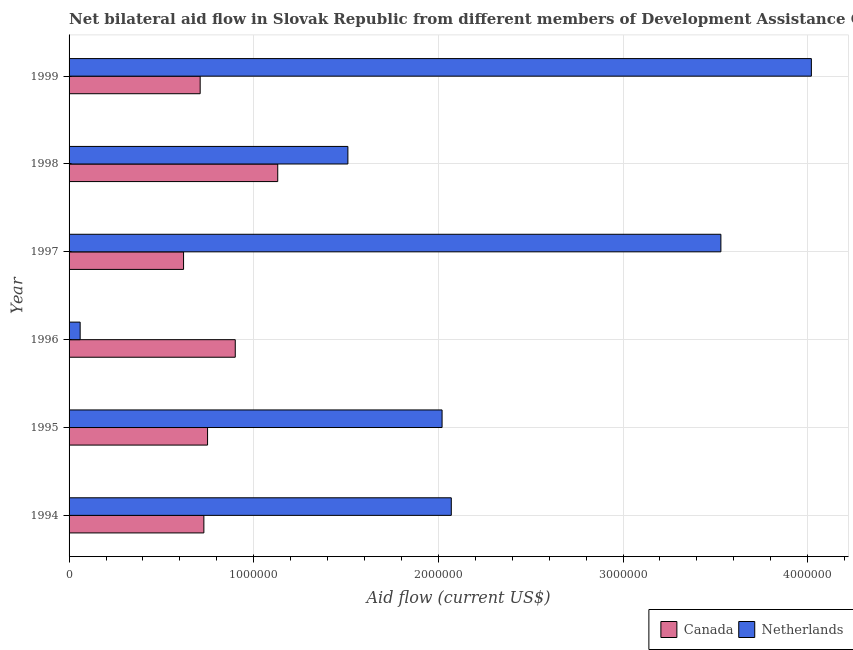How many groups of bars are there?
Give a very brief answer. 6. How many bars are there on the 6th tick from the top?
Make the answer very short. 2. How many bars are there on the 1st tick from the bottom?
Offer a terse response. 2. In how many cases, is the number of bars for a given year not equal to the number of legend labels?
Your response must be concise. 0. What is the amount of aid given by canada in 1998?
Provide a succinct answer. 1.13e+06. Across all years, what is the maximum amount of aid given by netherlands?
Your answer should be compact. 4.02e+06. Across all years, what is the minimum amount of aid given by netherlands?
Keep it short and to the point. 6.00e+04. In which year was the amount of aid given by netherlands maximum?
Offer a very short reply. 1999. What is the total amount of aid given by netherlands in the graph?
Ensure brevity in your answer.  1.32e+07. What is the difference between the amount of aid given by netherlands in 1997 and that in 1998?
Provide a short and direct response. 2.02e+06. What is the difference between the amount of aid given by netherlands in 1997 and the amount of aid given by canada in 1994?
Ensure brevity in your answer.  2.80e+06. What is the average amount of aid given by canada per year?
Make the answer very short. 8.07e+05. In the year 1996, what is the difference between the amount of aid given by canada and amount of aid given by netherlands?
Provide a short and direct response. 8.40e+05. In how many years, is the amount of aid given by canada greater than 3000000 US$?
Make the answer very short. 0. What is the ratio of the amount of aid given by canada in 1996 to that in 1999?
Provide a succinct answer. 1.27. Is the difference between the amount of aid given by netherlands in 1995 and 1999 greater than the difference between the amount of aid given by canada in 1995 and 1999?
Provide a succinct answer. No. What is the difference between the highest and the lowest amount of aid given by canada?
Offer a very short reply. 5.10e+05. In how many years, is the amount of aid given by netherlands greater than the average amount of aid given by netherlands taken over all years?
Offer a very short reply. 2. Is the sum of the amount of aid given by canada in 1996 and 1999 greater than the maximum amount of aid given by netherlands across all years?
Offer a very short reply. No. How many bars are there?
Your response must be concise. 12. What is the difference between two consecutive major ticks on the X-axis?
Offer a terse response. 1.00e+06. Does the graph contain any zero values?
Provide a succinct answer. No. Where does the legend appear in the graph?
Give a very brief answer. Bottom right. How many legend labels are there?
Offer a very short reply. 2. How are the legend labels stacked?
Give a very brief answer. Horizontal. What is the title of the graph?
Give a very brief answer. Net bilateral aid flow in Slovak Republic from different members of Development Assistance Committee. What is the label or title of the X-axis?
Offer a terse response. Aid flow (current US$). What is the label or title of the Y-axis?
Provide a succinct answer. Year. What is the Aid flow (current US$) of Canada in 1994?
Give a very brief answer. 7.30e+05. What is the Aid flow (current US$) in Netherlands in 1994?
Offer a terse response. 2.07e+06. What is the Aid flow (current US$) of Canada in 1995?
Your answer should be very brief. 7.50e+05. What is the Aid flow (current US$) in Netherlands in 1995?
Give a very brief answer. 2.02e+06. What is the Aid flow (current US$) of Canada in 1996?
Offer a terse response. 9.00e+05. What is the Aid flow (current US$) of Netherlands in 1996?
Your answer should be compact. 6.00e+04. What is the Aid flow (current US$) of Canada in 1997?
Offer a terse response. 6.20e+05. What is the Aid flow (current US$) of Netherlands in 1997?
Your response must be concise. 3.53e+06. What is the Aid flow (current US$) of Canada in 1998?
Make the answer very short. 1.13e+06. What is the Aid flow (current US$) in Netherlands in 1998?
Provide a succinct answer. 1.51e+06. What is the Aid flow (current US$) in Canada in 1999?
Give a very brief answer. 7.10e+05. What is the Aid flow (current US$) of Netherlands in 1999?
Provide a short and direct response. 4.02e+06. Across all years, what is the maximum Aid flow (current US$) of Canada?
Give a very brief answer. 1.13e+06. Across all years, what is the maximum Aid flow (current US$) in Netherlands?
Give a very brief answer. 4.02e+06. Across all years, what is the minimum Aid flow (current US$) of Canada?
Keep it short and to the point. 6.20e+05. Across all years, what is the minimum Aid flow (current US$) of Netherlands?
Keep it short and to the point. 6.00e+04. What is the total Aid flow (current US$) in Canada in the graph?
Your response must be concise. 4.84e+06. What is the total Aid flow (current US$) of Netherlands in the graph?
Keep it short and to the point. 1.32e+07. What is the difference between the Aid flow (current US$) in Canada in 1994 and that in 1995?
Your response must be concise. -2.00e+04. What is the difference between the Aid flow (current US$) of Netherlands in 1994 and that in 1996?
Provide a short and direct response. 2.01e+06. What is the difference between the Aid flow (current US$) of Netherlands in 1994 and that in 1997?
Your response must be concise. -1.46e+06. What is the difference between the Aid flow (current US$) of Canada in 1994 and that in 1998?
Your response must be concise. -4.00e+05. What is the difference between the Aid flow (current US$) in Netherlands in 1994 and that in 1998?
Offer a terse response. 5.60e+05. What is the difference between the Aid flow (current US$) in Canada in 1994 and that in 1999?
Offer a terse response. 2.00e+04. What is the difference between the Aid flow (current US$) of Netherlands in 1994 and that in 1999?
Your answer should be compact. -1.95e+06. What is the difference between the Aid flow (current US$) of Canada in 1995 and that in 1996?
Your response must be concise. -1.50e+05. What is the difference between the Aid flow (current US$) in Netherlands in 1995 and that in 1996?
Ensure brevity in your answer.  1.96e+06. What is the difference between the Aid flow (current US$) of Canada in 1995 and that in 1997?
Provide a succinct answer. 1.30e+05. What is the difference between the Aid flow (current US$) in Netherlands in 1995 and that in 1997?
Provide a succinct answer. -1.51e+06. What is the difference between the Aid flow (current US$) in Canada in 1995 and that in 1998?
Keep it short and to the point. -3.80e+05. What is the difference between the Aid flow (current US$) in Netherlands in 1995 and that in 1998?
Make the answer very short. 5.10e+05. What is the difference between the Aid flow (current US$) of Netherlands in 1995 and that in 1999?
Ensure brevity in your answer.  -2.00e+06. What is the difference between the Aid flow (current US$) of Canada in 1996 and that in 1997?
Give a very brief answer. 2.80e+05. What is the difference between the Aid flow (current US$) of Netherlands in 1996 and that in 1997?
Keep it short and to the point. -3.47e+06. What is the difference between the Aid flow (current US$) of Canada in 1996 and that in 1998?
Provide a succinct answer. -2.30e+05. What is the difference between the Aid flow (current US$) in Netherlands in 1996 and that in 1998?
Provide a succinct answer. -1.45e+06. What is the difference between the Aid flow (current US$) of Netherlands in 1996 and that in 1999?
Provide a succinct answer. -3.96e+06. What is the difference between the Aid flow (current US$) in Canada in 1997 and that in 1998?
Provide a succinct answer. -5.10e+05. What is the difference between the Aid flow (current US$) of Netherlands in 1997 and that in 1998?
Give a very brief answer. 2.02e+06. What is the difference between the Aid flow (current US$) of Netherlands in 1997 and that in 1999?
Provide a succinct answer. -4.90e+05. What is the difference between the Aid flow (current US$) of Netherlands in 1998 and that in 1999?
Your answer should be compact. -2.51e+06. What is the difference between the Aid flow (current US$) in Canada in 1994 and the Aid flow (current US$) in Netherlands in 1995?
Ensure brevity in your answer.  -1.29e+06. What is the difference between the Aid flow (current US$) of Canada in 1994 and the Aid flow (current US$) of Netherlands in 1996?
Offer a very short reply. 6.70e+05. What is the difference between the Aid flow (current US$) in Canada in 1994 and the Aid flow (current US$) in Netherlands in 1997?
Provide a short and direct response. -2.80e+06. What is the difference between the Aid flow (current US$) of Canada in 1994 and the Aid flow (current US$) of Netherlands in 1998?
Ensure brevity in your answer.  -7.80e+05. What is the difference between the Aid flow (current US$) in Canada in 1994 and the Aid flow (current US$) in Netherlands in 1999?
Your response must be concise. -3.29e+06. What is the difference between the Aid flow (current US$) in Canada in 1995 and the Aid flow (current US$) in Netherlands in 1996?
Keep it short and to the point. 6.90e+05. What is the difference between the Aid flow (current US$) of Canada in 1995 and the Aid flow (current US$) of Netherlands in 1997?
Your response must be concise. -2.78e+06. What is the difference between the Aid flow (current US$) of Canada in 1995 and the Aid flow (current US$) of Netherlands in 1998?
Provide a short and direct response. -7.60e+05. What is the difference between the Aid flow (current US$) in Canada in 1995 and the Aid flow (current US$) in Netherlands in 1999?
Provide a succinct answer. -3.27e+06. What is the difference between the Aid flow (current US$) in Canada in 1996 and the Aid flow (current US$) in Netherlands in 1997?
Offer a terse response. -2.63e+06. What is the difference between the Aid flow (current US$) of Canada in 1996 and the Aid flow (current US$) of Netherlands in 1998?
Ensure brevity in your answer.  -6.10e+05. What is the difference between the Aid flow (current US$) of Canada in 1996 and the Aid flow (current US$) of Netherlands in 1999?
Provide a succinct answer. -3.12e+06. What is the difference between the Aid flow (current US$) in Canada in 1997 and the Aid flow (current US$) in Netherlands in 1998?
Keep it short and to the point. -8.90e+05. What is the difference between the Aid flow (current US$) of Canada in 1997 and the Aid flow (current US$) of Netherlands in 1999?
Offer a very short reply. -3.40e+06. What is the difference between the Aid flow (current US$) of Canada in 1998 and the Aid flow (current US$) of Netherlands in 1999?
Make the answer very short. -2.89e+06. What is the average Aid flow (current US$) in Canada per year?
Provide a short and direct response. 8.07e+05. What is the average Aid flow (current US$) of Netherlands per year?
Your answer should be very brief. 2.20e+06. In the year 1994, what is the difference between the Aid flow (current US$) of Canada and Aid flow (current US$) of Netherlands?
Your answer should be very brief. -1.34e+06. In the year 1995, what is the difference between the Aid flow (current US$) in Canada and Aid flow (current US$) in Netherlands?
Ensure brevity in your answer.  -1.27e+06. In the year 1996, what is the difference between the Aid flow (current US$) in Canada and Aid flow (current US$) in Netherlands?
Your answer should be very brief. 8.40e+05. In the year 1997, what is the difference between the Aid flow (current US$) of Canada and Aid flow (current US$) of Netherlands?
Your response must be concise. -2.91e+06. In the year 1998, what is the difference between the Aid flow (current US$) in Canada and Aid flow (current US$) in Netherlands?
Make the answer very short. -3.80e+05. In the year 1999, what is the difference between the Aid flow (current US$) in Canada and Aid flow (current US$) in Netherlands?
Make the answer very short. -3.31e+06. What is the ratio of the Aid flow (current US$) in Canada in 1994 to that in 1995?
Offer a very short reply. 0.97. What is the ratio of the Aid flow (current US$) of Netherlands in 1994 to that in 1995?
Make the answer very short. 1.02. What is the ratio of the Aid flow (current US$) in Canada in 1994 to that in 1996?
Give a very brief answer. 0.81. What is the ratio of the Aid flow (current US$) in Netherlands in 1994 to that in 1996?
Give a very brief answer. 34.5. What is the ratio of the Aid flow (current US$) in Canada in 1994 to that in 1997?
Give a very brief answer. 1.18. What is the ratio of the Aid flow (current US$) of Netherlands in 1994 to that in 1997?
Give a very brief answer. 0.59. What is the ratio of the Aid flow (current US$) in Canada in 1994 to that in 1998?
Give a very brief answer. 0.65. What is the ratio of the Aid flow (current US$) in Netherlands in 1994 to that in 1998?
Make the answer very short. 1.37. What is the ratio of the Aid flow (current US$) of Canada in 1994 to that in 1999?
Offer a very short reply. 1.03. What is the ratio of the Aid flow (current US$) in Netherlands in 1994 to that in 1999?
Your answer should be very brief. 0.51. What is the ratio of the Aid flow (current US$) in Canada in 1995 to that in 1996?
Your response must be concise. 0.83. What is the ratio of the Aid flow (current US$) in Netherlands in 1995 to that in 1996?
Offer a very short reply. 33.67. What is the ratio of the Aid flow (current US$) in Canada in 1995 to that in 1997?
Your answer should be very brief. 1.21. What is the ratio of the Aid flow (current US$) of Netherlands in 1995 to that in 1997?
Offer a very short reply. 0.57. What is the ratio of the Aid flow (current US$) of Canada in 1995 to that in 1998?
Provide a short and direct response. 0.66. What is the ratio of the Aid flow (current US$) in Netherlands in 1995 to that in 1998?
Provide a short and direct response. 1.34. What is the ratio of the Aid flow (current US$) of Canada in 1995 to that in 1999?
Offer a terse response. 1.06. What is the ratio of the Aid flow (current US$) of Netherlands in 1995 to that in 1999?
Your answer should be very brief. 0.5. What is the ratio of the Aid flow (current US$) of Canada in 1996 to that in 1997?
Give a very brief answer. 1.45. What is the ratio of the Aid flow (current US$) of Netherlands in 1996 to that in 1997?
Offer a terse response. 0.02. What is the ratio of the Aid flow (current US$) of Canada in 1996 to that in 1998?
Offer a very short reply. 0.8. What is the ratio of the Aid flow (current US$) of Netherlands in 1996 to that in 1998?
Give a very brief answer. 0.04. What is the ratio of the Aid flow (current US$) of Canada in 1996 to that in 1999?
Your response must be concise. 1.27. What is the ratio of the Aid flow (current US$) in Netherlands in 1996 to that in 1999?
Offer a terse response. 0.01. What is the ratio of the Aid flow (current US$) of Canada in 1997 to that in 1998?
Give a very brief answer. 0.55. What is the ratio of the Aid flow (current US$) in Netherlands in 1997 to that in 1998?
Provide a short and direct response. 2.34. What is the ratio of the Aid flow (current US$) in Canada in 1997 to that in 1999?
Keep it short and to the point. 0.87. What is the ratio of the Aid flow (current US$) of Netherlands in 1997 to that in 1999?
Make the answer very short. 0.88. What is the ratio of the Aid flow (current US$) in Canada in 1998 to that in 1999?
Your answer should be compact. 1.59. What is the ratio of the Aid flow (current US$) of Netherlands in 1998 to that in 1999?
Offer a terse response. 0.38. What is the difference between the highest and the second highest Aid flow (current US$) in Canada?
Make the answer very short. 2.30e+05. What is the difference between the highest and the lowest Aid flow (current US$) of Canada?
Provide a succinct answer. 5.10e+05. What is the difference between the highest and the lowest Aid flow (current US$) in Netherlands?
Your response must be concise. 3.96e+06. 